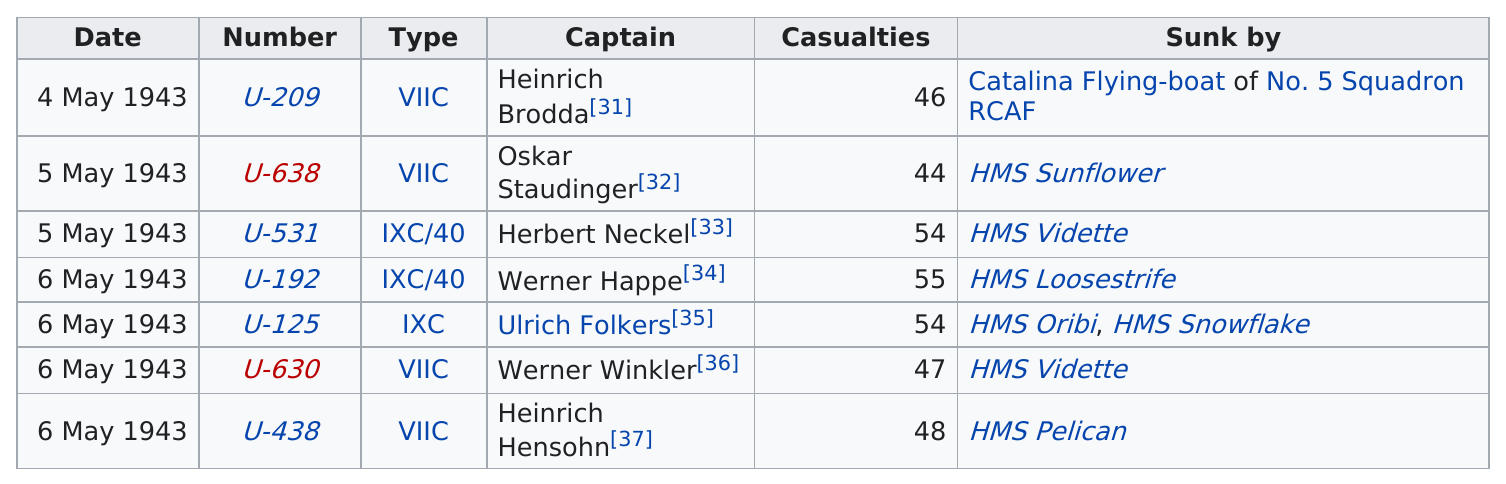List a handful of essential elements in this visual. The largest casualty in the history of the U-boat was 55. On May 6, 1943, a date had at least 55 casualties. On May 4, 1943, there were 46 casualties. Herbert Neckel was the other captain of the U-boat that was lost on May 5, aside from Oskar Staudinger. HMS Vidette was the ship that sank the most number of U-boats during World War II. 